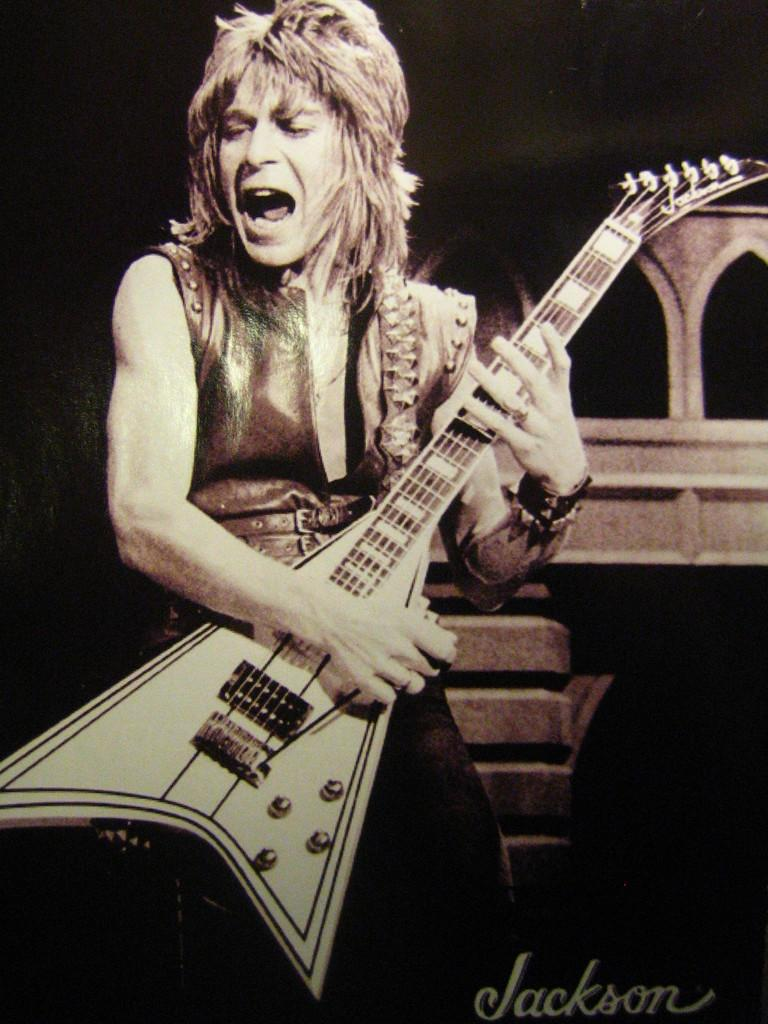What is the main subject of the image? There is a person in the image. What is the person doing in the image? The person is playing a guitar. What type of elbow support is the person using while playing the guitar in the image? There is no mention of an elbow support or any other accessory in the image; the person is simply playing the guitar. 